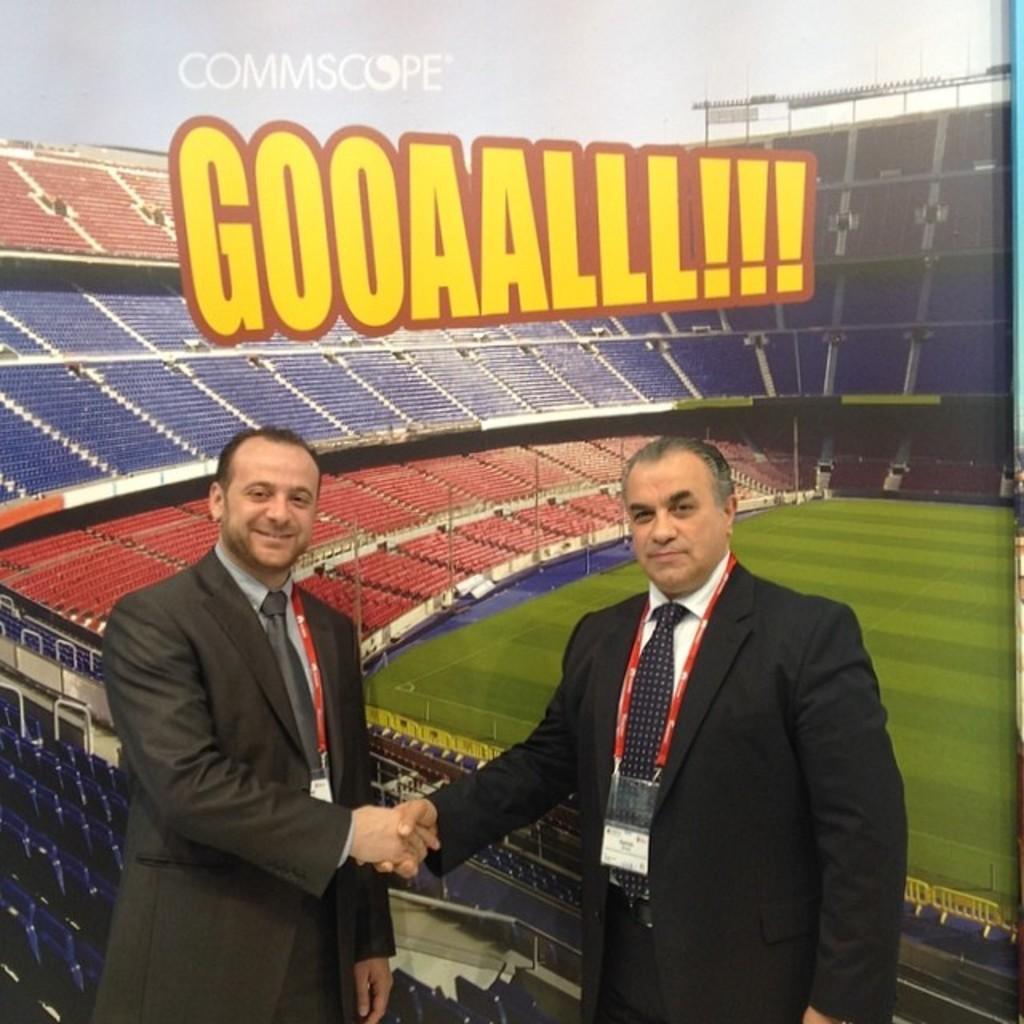How would you summarize this image in a sentence or two? 2 people are standing wearing suits and id cards. Behind them there is a banner of a stadium. 